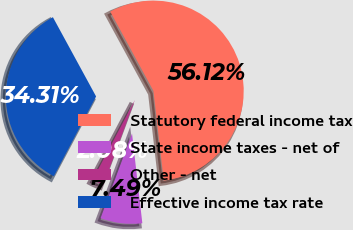<chart> <loc_0><loc_0><loc_500><loc_500><pie_chart><fcel>Statutory federal income tax<fcel>State income taxes - net of<fcel>Other - net<fcel>Effective income tax rate<nl><fcel>56.12%<fcel>7.49%<fcel>2.08%<fcel>34.31%<nl></chart> 